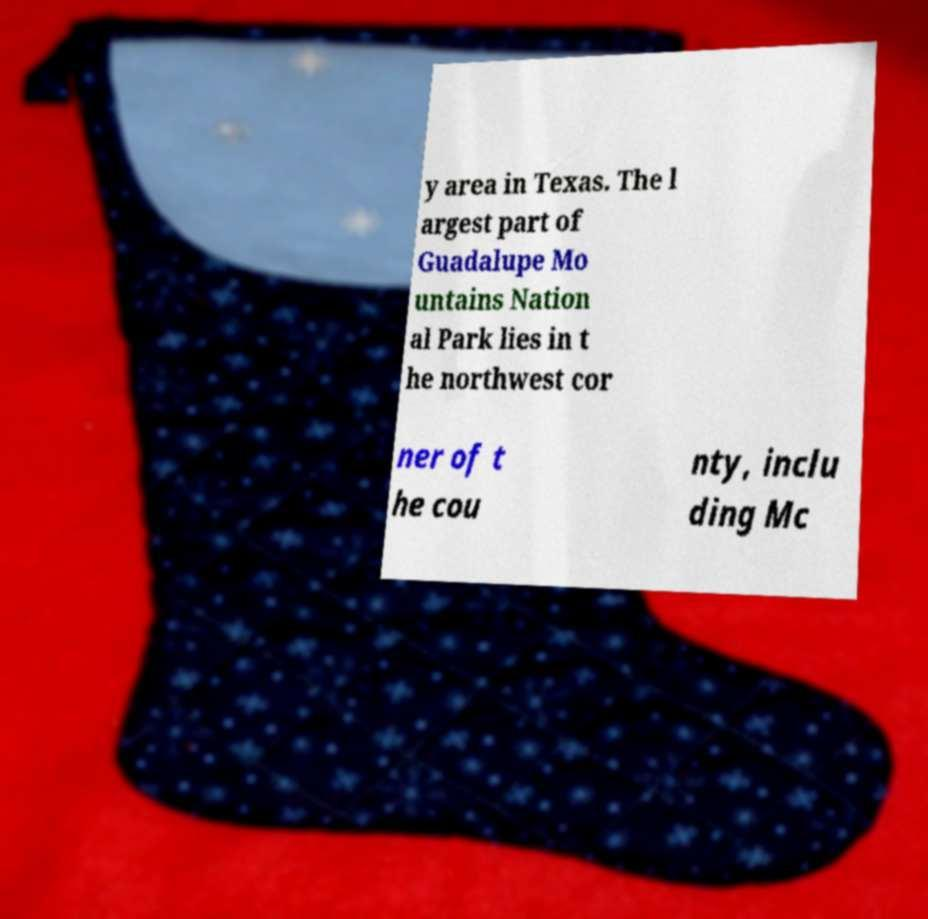Please identify and transcribe the text found in this image. y area in Texas. The l argest part of Guadalupe Mo untains Nation al Park lies in t he northwest cor ner of t he cou nty, inclu ding Mc 